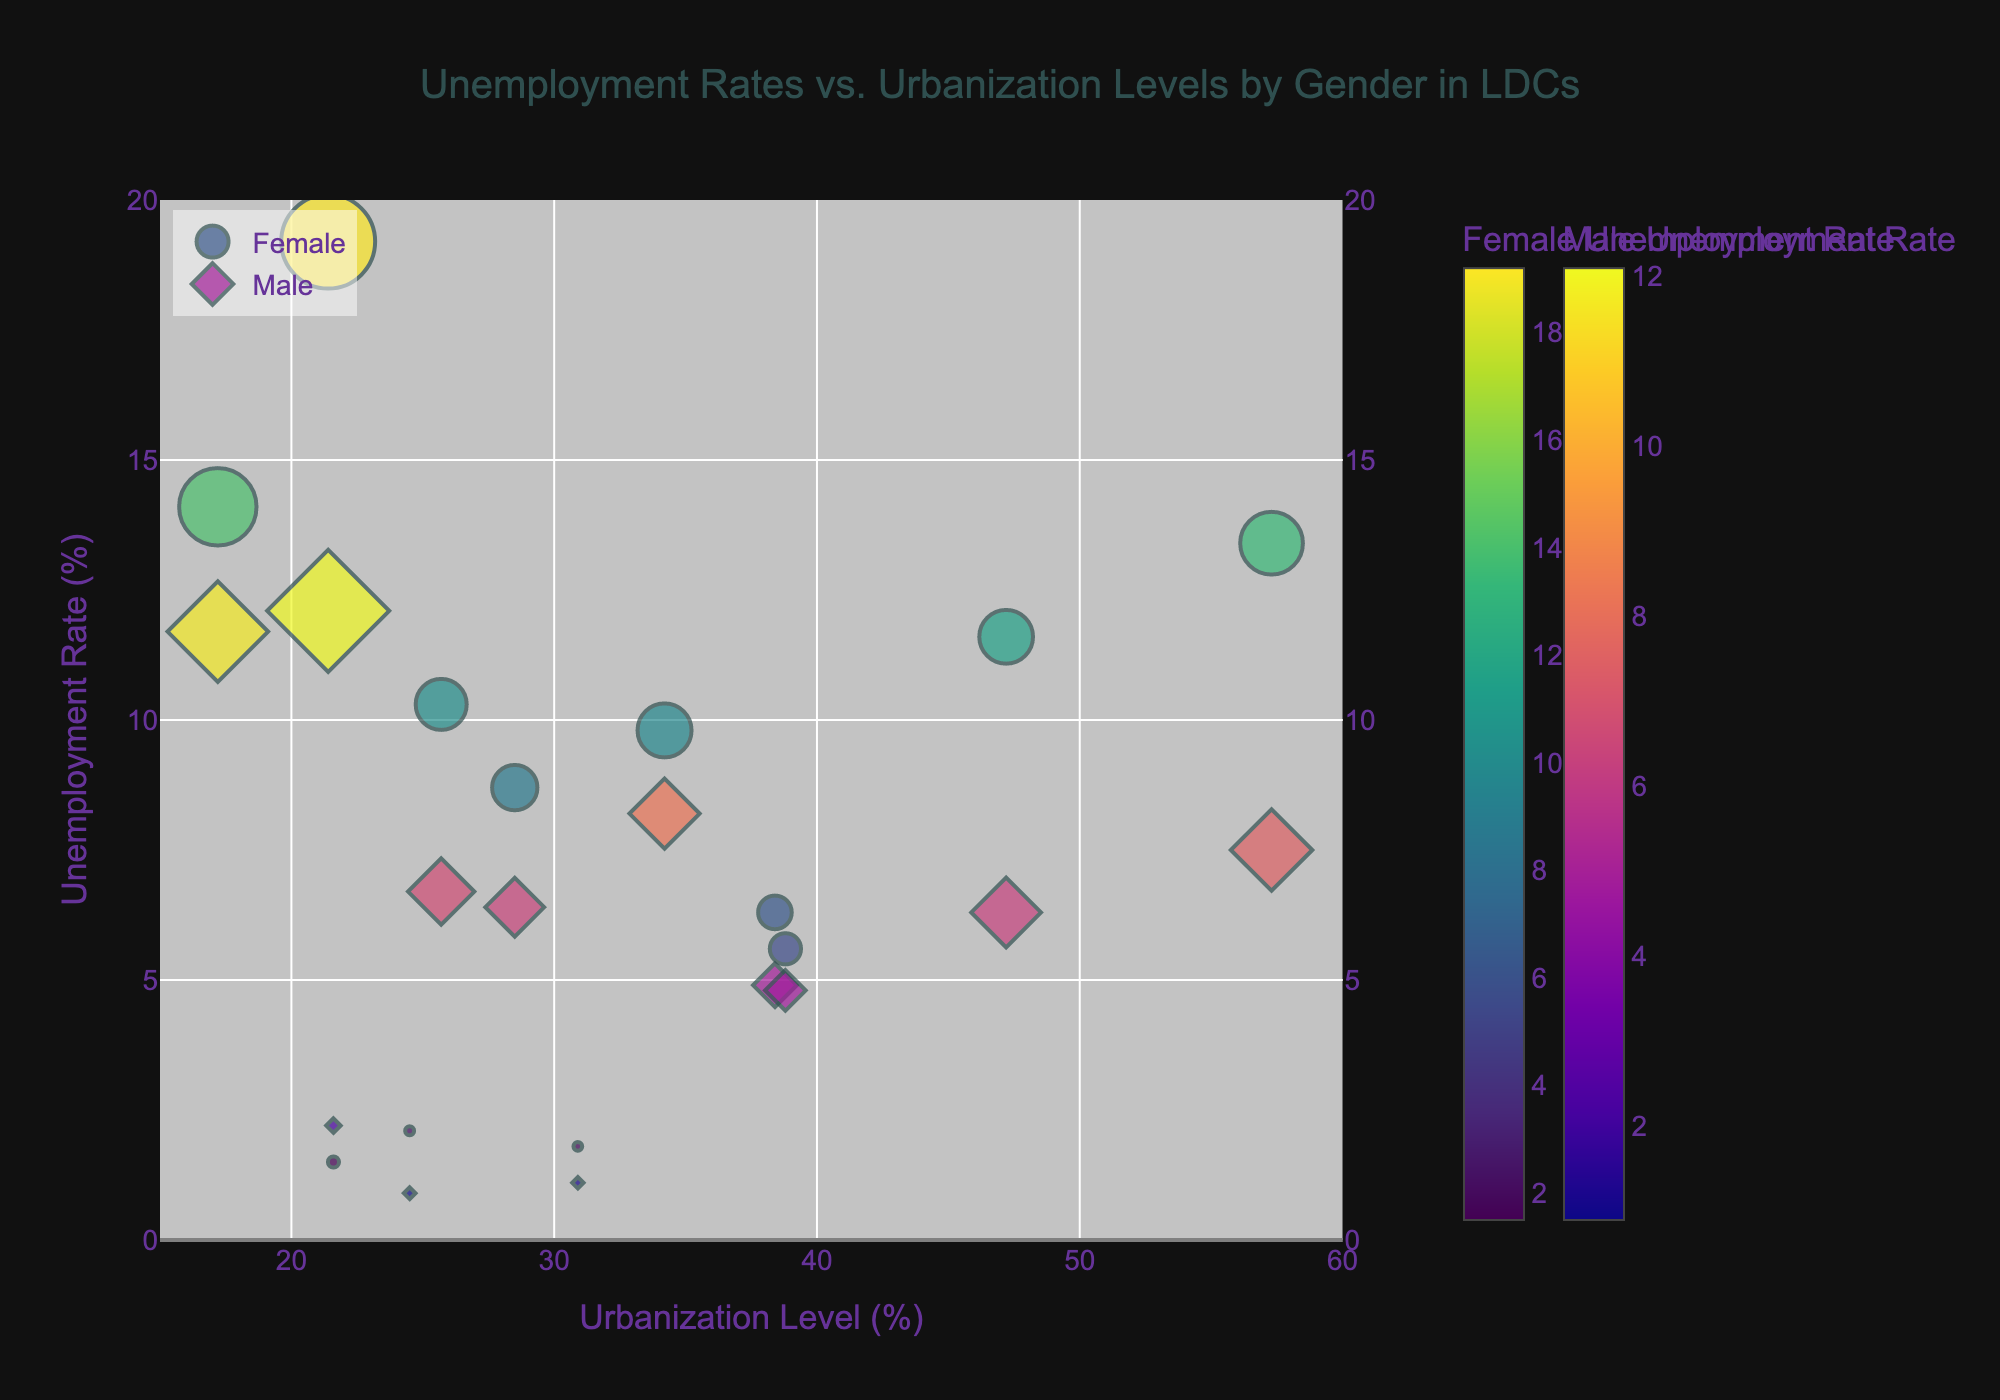How many countries are represented in the chart? The legend or the number of unique markers should correspond to the number of countries, each country being represented by two markers for male and female unemployment. The data list shows 12 countries.
Answer: 12 Which country has the highest female unemployment rate? Look for the female marker with the highest y-axis value representing female unemployment rates. Based on the input data, it is Ethiopia with 19.2%.
Answer: Ethiopia What is the general trend between urbanization level and female unemployment rate? Observe the overall direction of the scatter plot for female markers. While varied, there seems to be a slight increase in female unemployment rate as urbanization level increases, especially seen in countries like Haiti and Ethiopia.
Answer: Slight Increase Which country has the largest bubble and what does it represent? The size of the bubble represents the average unemployment rate, so the largest bubble corresponds to the highest average rate. Ethiopia has the largest bubble, indicating a high average unemployment rate of (19.2 + 12.1) / 2 = 15.65%.
Answer: Ethiopia How does male unemployment in Nepal compare to female unemployment in Nepal? Examine the markers for Nepal and compare their y-axis values. Female unemployment is 1.5% and male unemployment is 2.2%.
Answer: Lower Which country has the smallest difference between male and female unemployment rates? Calculate differences for each country and find the smallest one. Cambodia has 2.1% female and 0.9% male unemployment, a difference of 1.2%.
Answer: Cambodia Is there any country where female unemployment is lower than male unemployment? Review marker positions comparing the y-axis values. Nepal is an example with female unemployment at 1.5% and male at 2.2%.
Answer: Nepal What urbanization level corresponds to the highest male unemployment rate? Find the male marker with the highest y-axis value and its corresponding x-axis value. Rwanda, with male unemployment at 11.7%, has an urbanization level of 17.2%.
Answer: 17.2% Which country has the highest urbanization level and what is its female unemployment rate? Identify the country with the highest x-axis value and check its corresponding female marker y-axis value. Madagascar has 38.8% urbanization and a female unemployment rate of 5.6%.
Answer: Madagascar Among the countries with urbanization levels between 20% and 30%, which has the highest average unemployment rate? Filter markers within the 20-30% urbanization range and calculate their average unemployment rates. Ethiopia, with 21.4% urbanization, has the highest average rate at (19.2 + 12.1) / 2 = 15.65%.
Answer: Ethiopia 